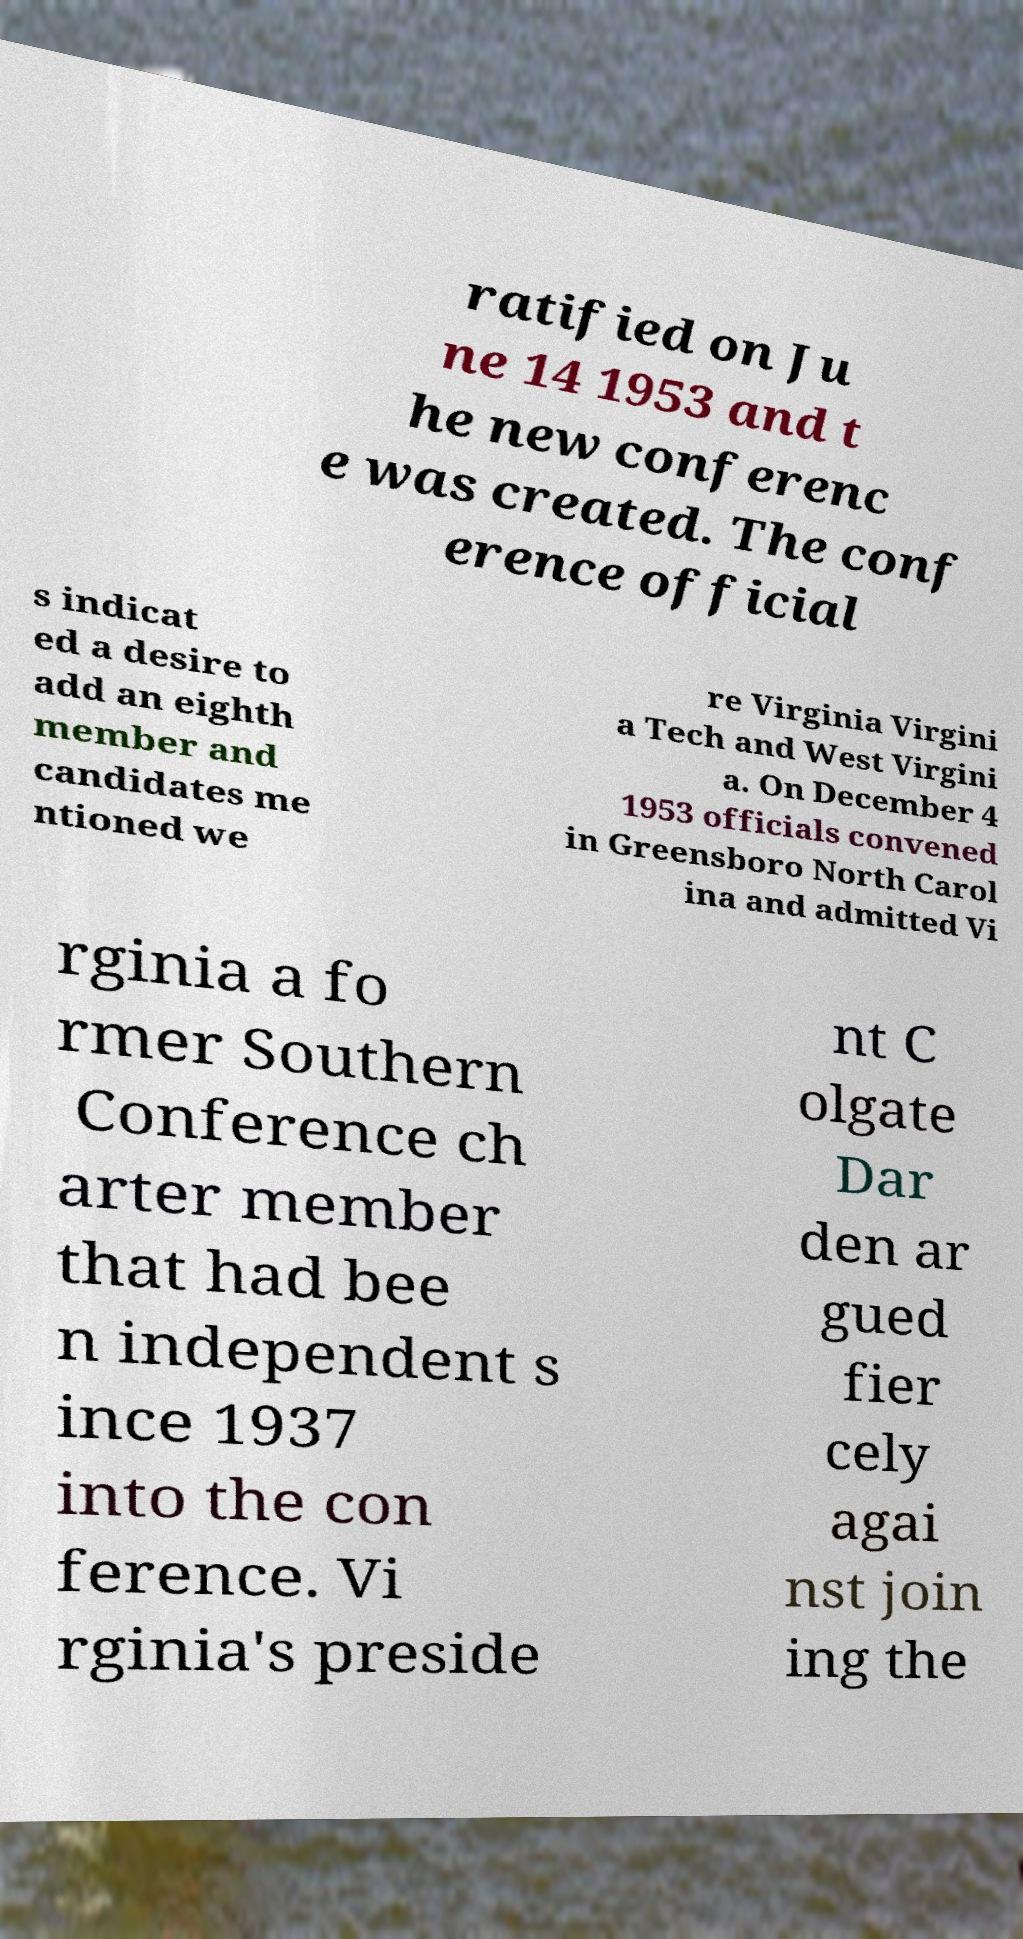Please identify and transcribe the text found in this image. ratified on Ju ne 14 1953 and t he new conferenc e was created. The conf erence official s indicat ed a desire to add an eighth member and candidates me ntioned we re Virginia Virgini a Tech and West Virgini a. On December 4 1953 officials convened in Greensboro North Carol ina and admitted Vi rginia a fo rmer Southern Conference ch arter member that had bee n independent s ince 1937 into the con ference. Vi rginia's preside nt C olgate Dar den ar gued fier cely agai nst join ing the 